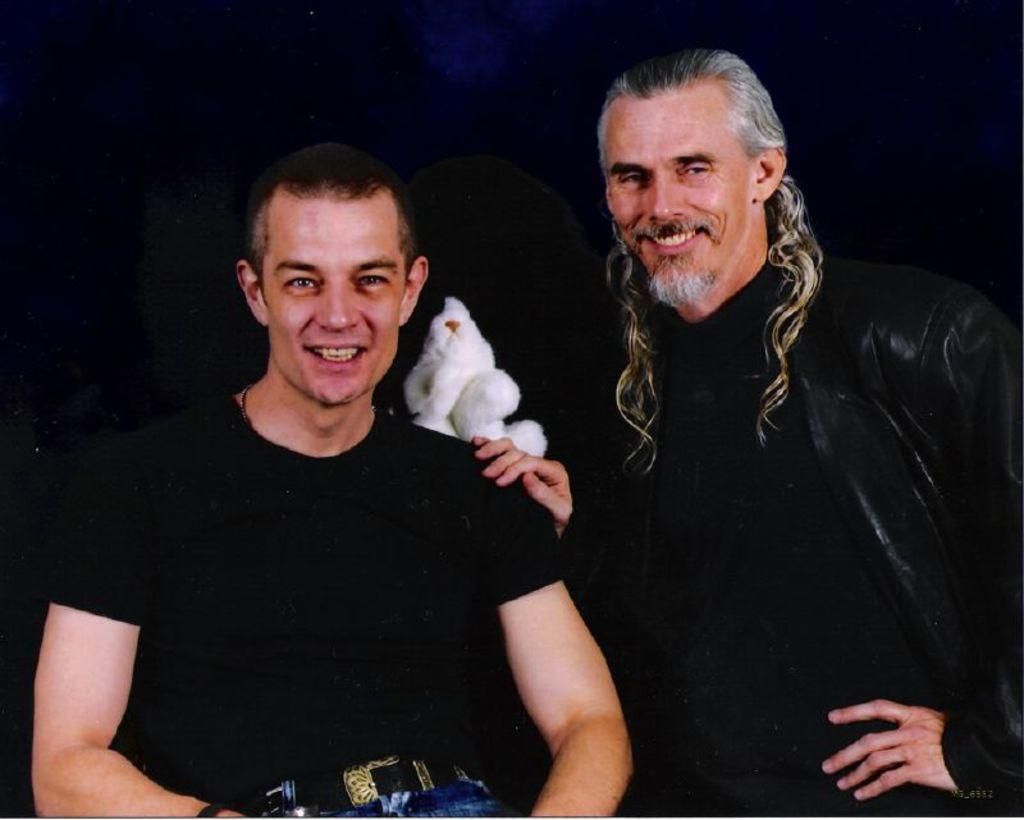What is happening in the foreground of the image? There are two men in the foreground of the image, one sitting and one standing. The standing man is wearing a black dress. Can you describe the background of the image? The background of the image is black. What can be seen in the background of the image? There is a white toy in the background of the image. How many pigs are visible in the image? There are no pigs present in the image. What type of base is supporting the white toy in the image? There is no base visible in the image; only the white toy can be seen in the background. 